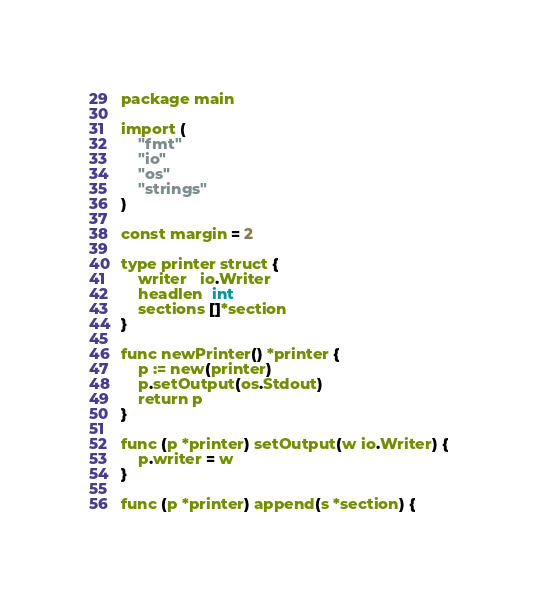<code> <loc_0><loc_0><loc_500><loc_500><_Go_>package main

import (
	"fmt"
	"io"
	"os"
	"strings"
)

const margin = 2

type printer struct {
	writer   io.Writer
	headlen  int
	sections []*section
}

func newPrinter() *printer {
	p := new(printer)
	p.setOutput(os.Stdout)
	return p
}

func (p *printer) setOutput(w io.Writer) {
	p.writer = w
}

func (p *printer) append(s *section) {</code> 